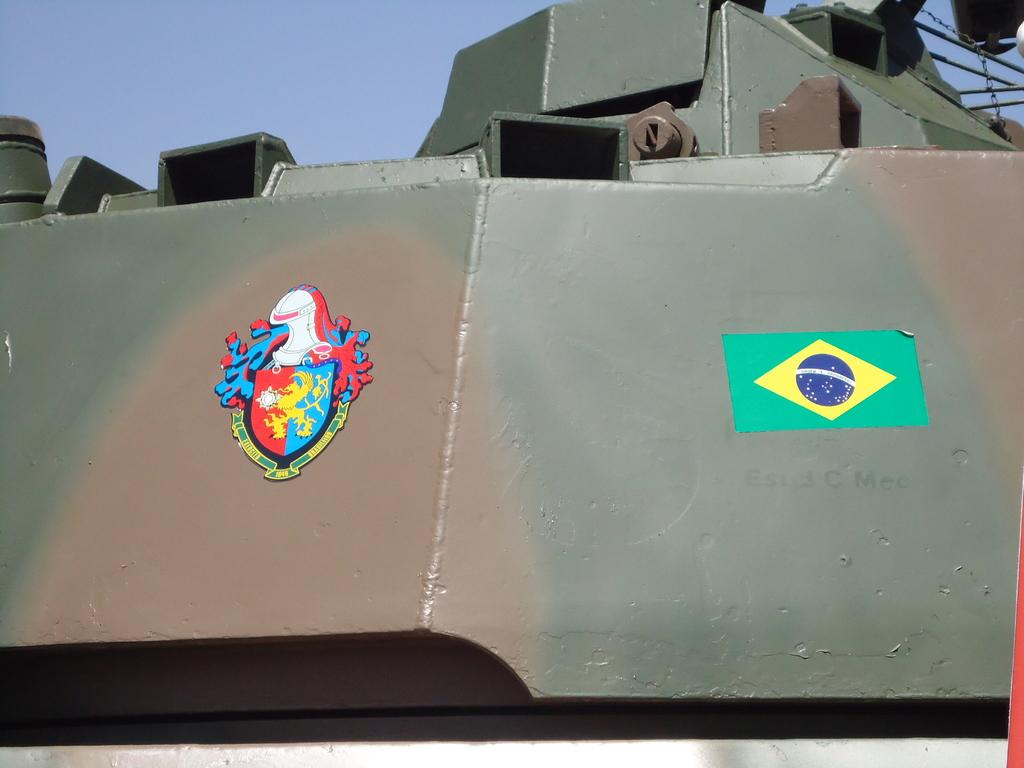What type of objects can be seen in the image? There are metal objects in the image. What else can be found in the image besides metal objects? There are stickers in the image. What color is the sky in the image? The sky is blue in the image. What type of temper can be seen in the image? There is no temper present in the image; it is a collection of metal objects and stickers. What kind of badge is visible in the image? There is no badge present in the image. 